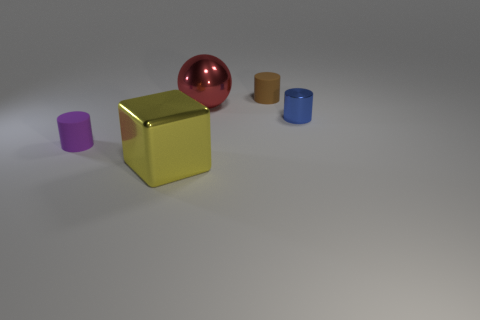What is the large yellow thing that is right of the matte thing that is to the left of the rubber object behind the big metal sphere made of? The large yellow object positioned to the right of the matte cube, which in turn is located to the left of the rubber cylinder behind the big metal sphere, appears to be a metallic cube itself, given its reflective surface and sharp edges that are typical of metal objects. 